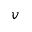<formula> <loc_0><loc_0><loc_500><loc_500>v</formula> 